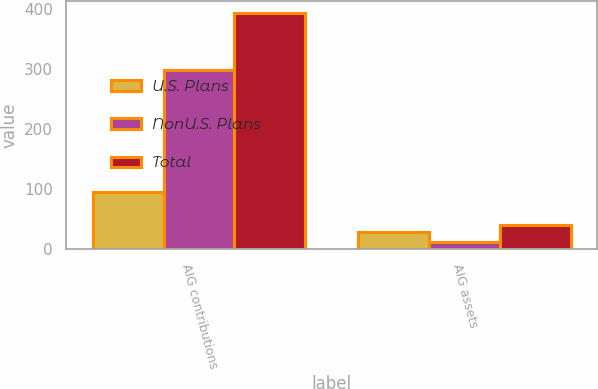Convert chart. <chart><loc_0><loc_0><loc_500><loc_500><stacked_bar_chart><ecel><fcel>AIG contributions<fcel>AIG assets<nl><fcel>U.S. Plans<fcel>95<fcel>28<nl><fcel>NonU.S. Plans<fcel>298<fcel>11<nl><fcel>Total<fcel>393<fcel>39<nl></chart> 